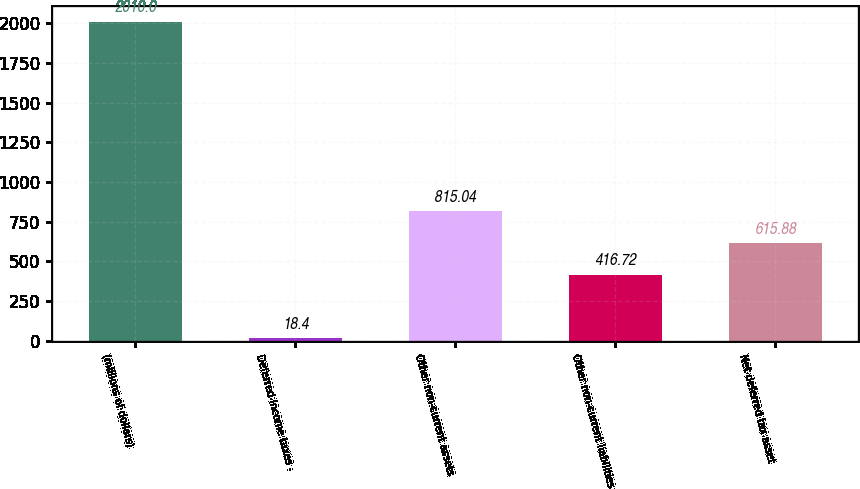<chart> <loc_0><loc_0><loc_500><loc_500><bar_chart><fcel>(millions of dollars)<fcel>Deferred income taxes -<fcel>Other non-current assets<fcel>Other non-current liabilities<fcel>Net deferred tax asset<nl><fcel>2010<fcel>18.4<fcel>815.04<fcel>416.72<fcel>615.88<nl></chart> 